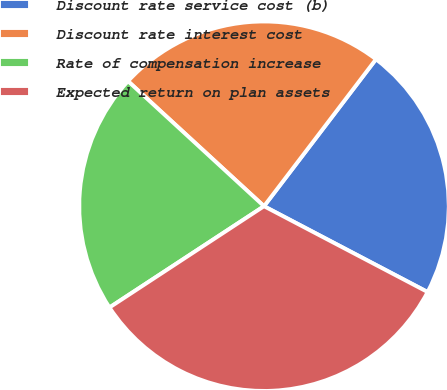Convert chart. <chart><loc_0><loc_0><loc_500><loc_500><pie_chart><fcel>Discount rate service cost (b)<fcel>Discount rate interest cost<fcel>Rate of compensation increase<fcel>Expected return on plan assets<nl><fcel>22.33%<fcel>23.53%<fcel>21.07%<fcel>33.08%<nl></chart> 